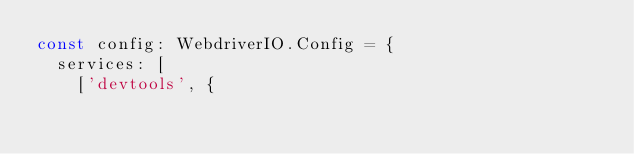<code> <loc_0><loc_0><loc_500><loc_500><_TypeScript_>const config: WebdriverIO.Config = {
  services: [
    ['devtools', {</code> 